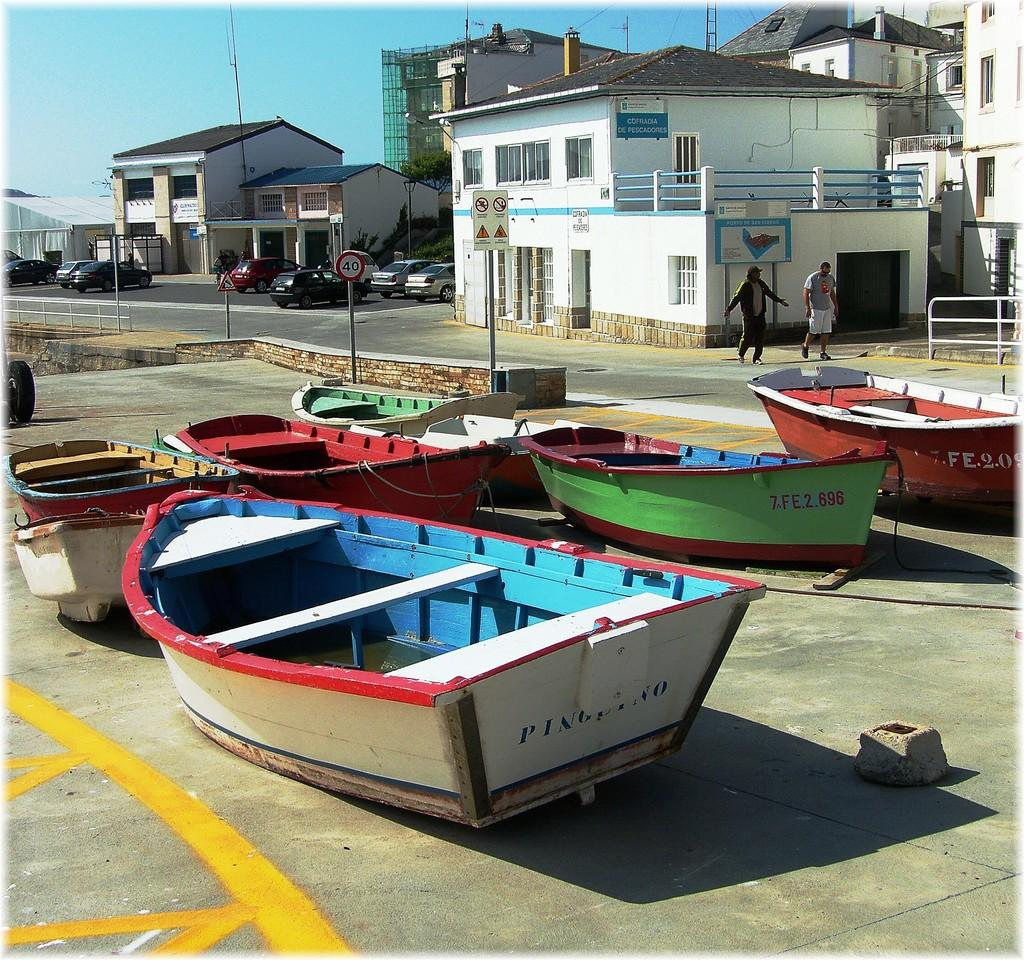What can be seen in the foreground of the image? There are boats in the foreground of the image. Are there any people visible in the image? Yes, there are people in the image. What is visible in the background of the image? There are houses, poles, vehicles, and the sky in the background of the image. How many crows are sitting on the poles in the image? There are no crows present in the image; only boats, people, houses, poles, vehicles, and the sky are visible. What type of bomb can be seen in the image? There is no bomb present in the image. 